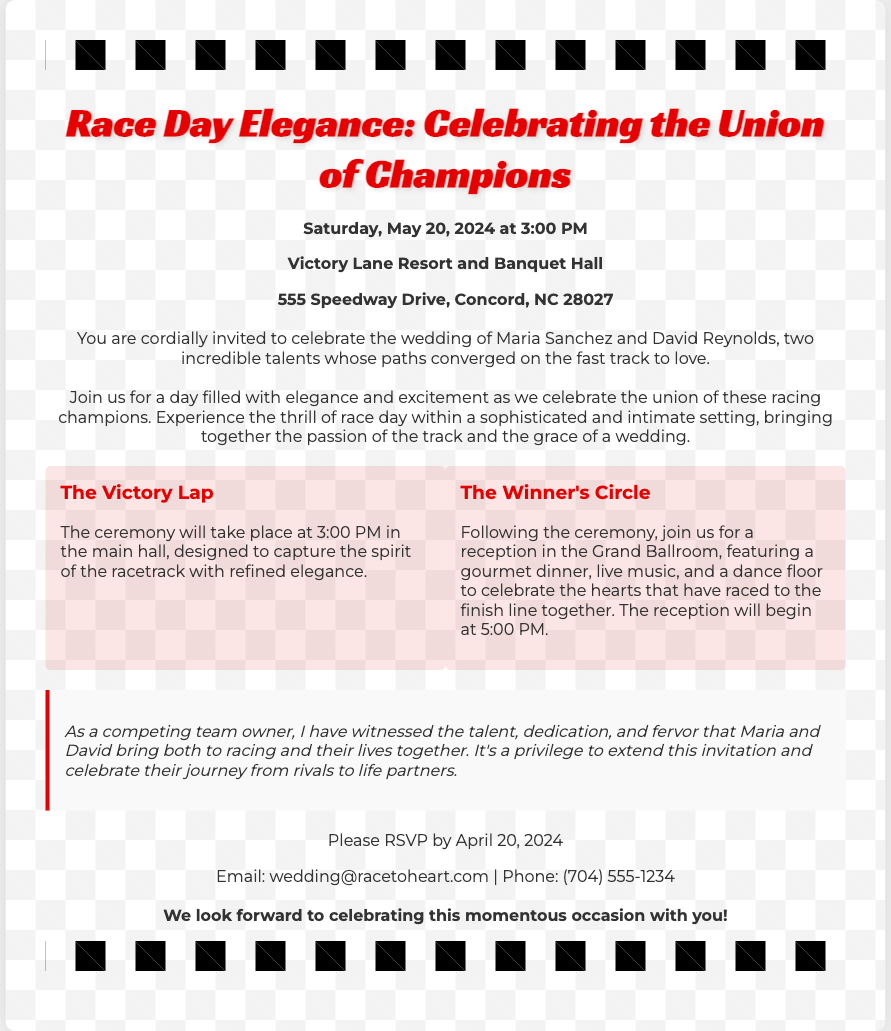What is the date of the wedding? The wedding is scheduled for Saturday, May 20, 2024.
Answer: Saturday, May 20, 2024 What time does the ceremony start? The ceremony will take place at 3:00 PM.
Answer: 3:00 PM Where is the wedding taking place? The venue is Victory Lane Resort and Banquet Hall, located at 555 Speedway Drive, Concord, NC 28027.
Answer: Victory Lane Resort and Banquet Hall Who are the couple getting married? The invitation mentions Maria Sanchez and David Reynolds as the couple.
Answer: Maria Sanchez and David Reynolds What event follows the ceremony? The reception follows the ceremony and is called "The Winner's Circle."
Answer: The Winner's Circle What time does the reception begin? The reception is set to begin at 5:00 PM.
Answer: 5:00 PM What should guests do by April 20, 2024? Guests are requested to RSVP by this date.
Answer: RSVP Why is the invitation special? It reflects the union of two racing champions and combines the excitement of racing with a wedding celebration.
Answer: Celebrating the union of champions 